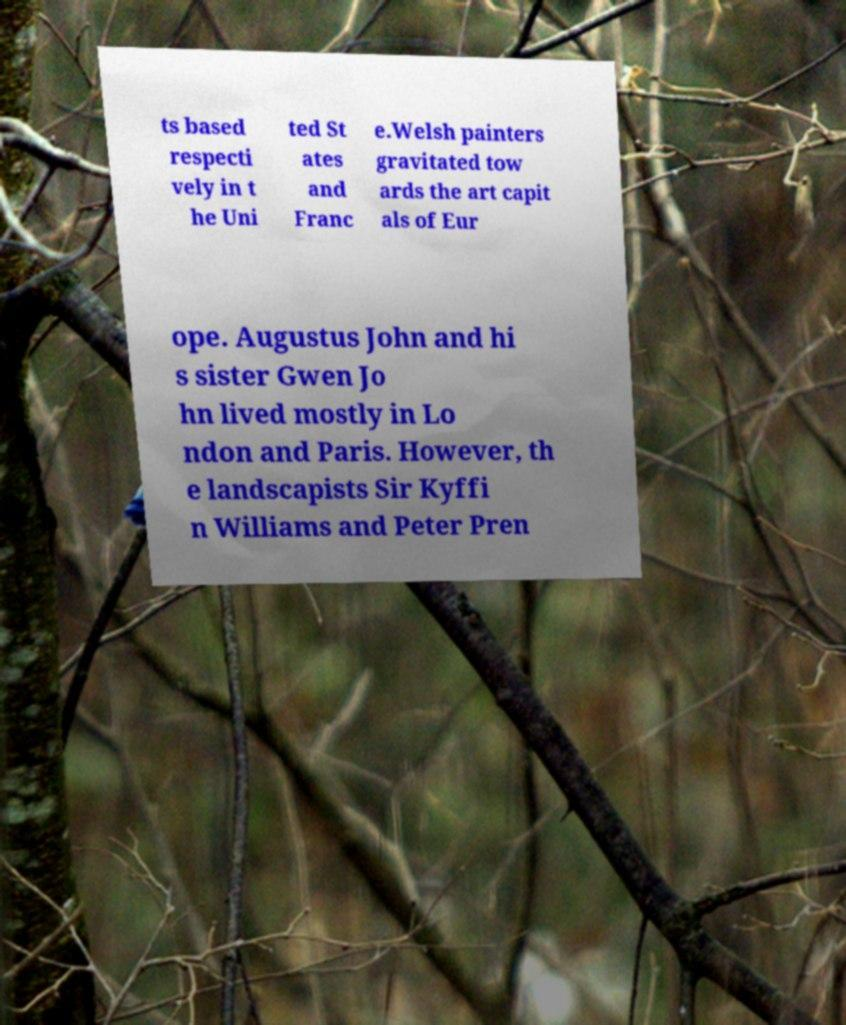Could you extract and type out the text from this image? ts based respecti vely in t he Uni ted St ates and Franc e.Welsh painters gravitated tow ards the art capit als of Eur ope. Augustus John and hi s sister Gwen Jo hn lived mostly in Lo ndon and Paris. However, th e landscapists Sir Kyffi n Williams and Peter Pren 